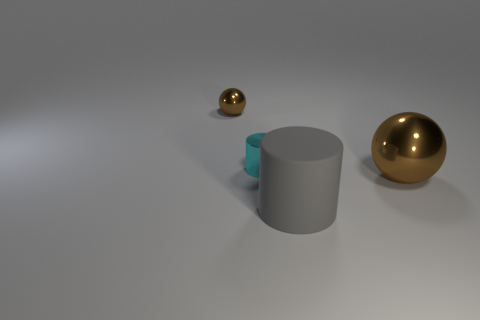Add 3 tiny brown metal balls. How many objects exist? 7 Add 2 small cyan objects. How many small cyan objects exist? 3 Subtract 0 purple balls. How many objects are left? 4 Subtract all large green shiny blocks. Subtract all big metallic things. How many objects are left? 3 Add 3 metallic balls. How many metallic balls are left? 5 